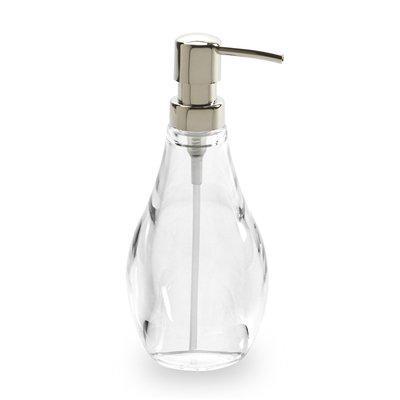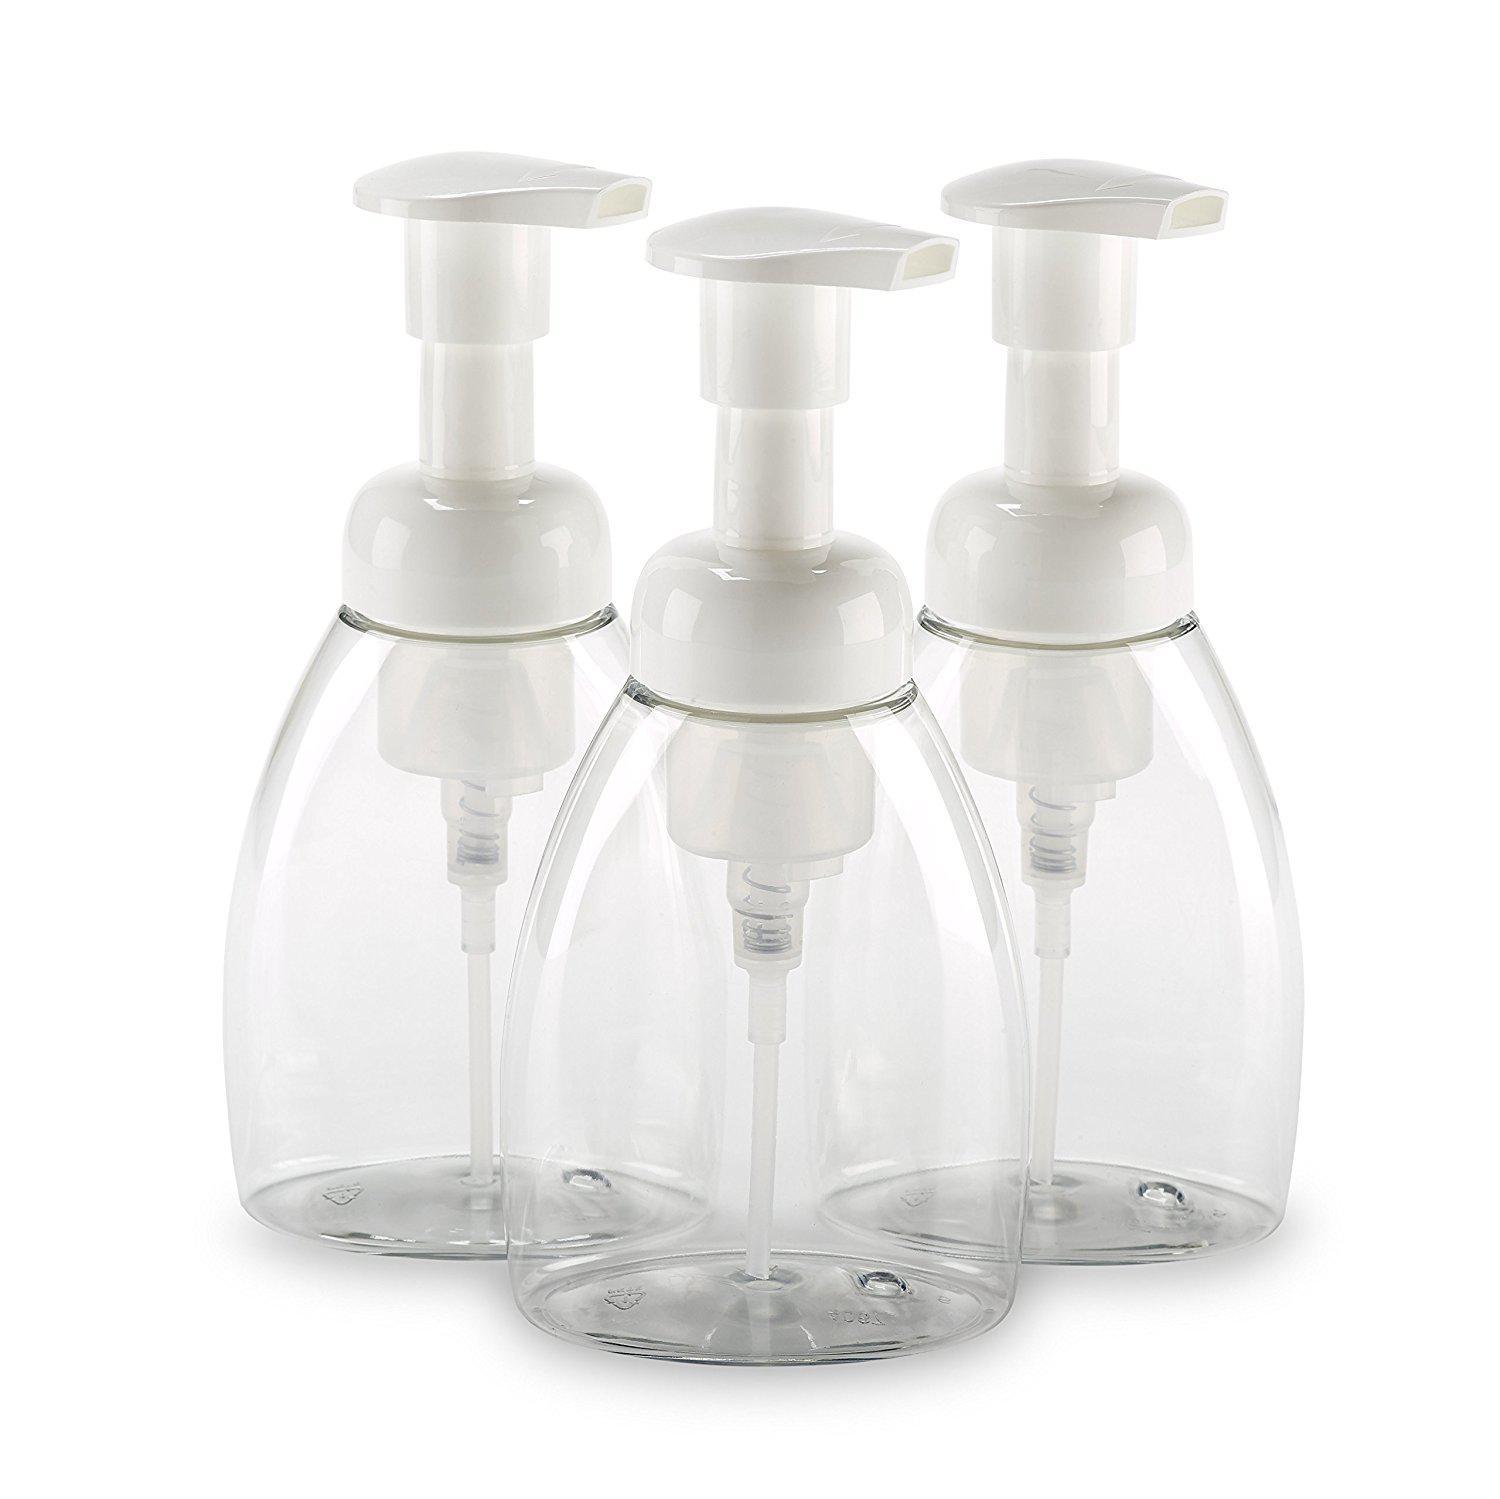The first image is the image on the left, the second image is the image on the right. Analyze the images presented: Is the assertion "The combined images show four complete pump-top dispensers, all of them transparent." valid? Answer yes or no. Yes. The first image is the image on the left, the second image is the image on the right. Evaluate the accuracy of this statement regarding the images: "The right image contains at least two dispensers.". Is it true? Answer yes or no. Yes. 